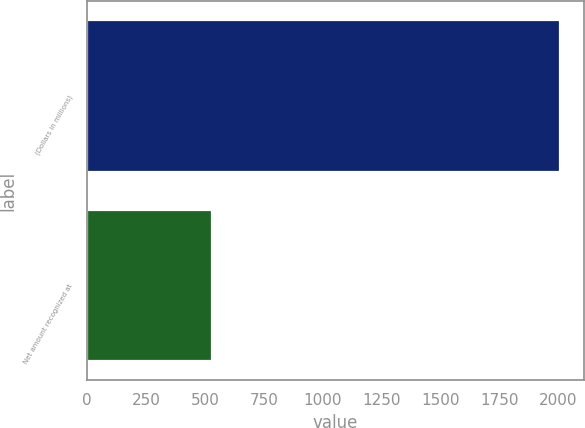<chart> <loc_0><loc_0><loc_500><loc_500><bar_chart><fcel>(Dollars in millions)<fcel>Net amount recognized at<nl><fcel>2008<fcel>530<nl></chart> 